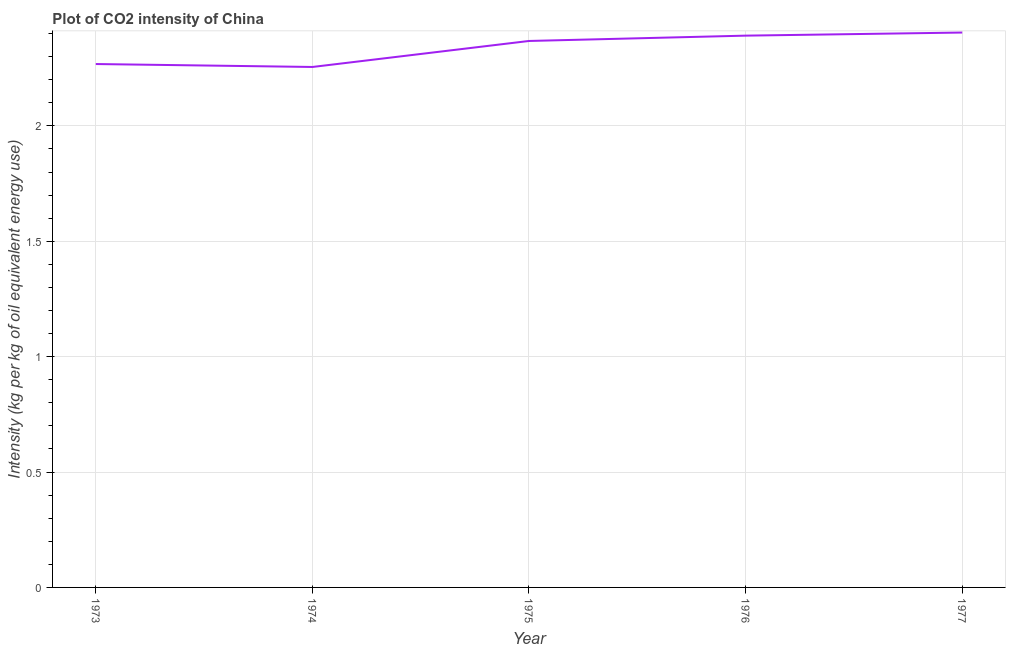What is the co2 intensity in 1973?
Provide a succinct answer. 2.27. Across all years, what is the maximum co2 intensity?
Provide a short and direct response. 2.4. Across all years, what is the minimum co2 intensity?
Ensure brevity in your answer.  2.26. In which year was the co2 intensity maximum?
Your answer should be compact. 1977. In which year was the co2 intensity minimum?
Your response must be concise. 1974. What is the sum of the co2 intensity?
Your answer should be very brief. 11.69. What is the difference between the co2 intensity in 1974 and 1976?
Give a very brief answer. -0.14. What is the average co2 intensity per year?
Keep it short and to the point. 2.34. What is the median co2 intensity?
Make the answer very short. 2.37. In how many years, is the co2 intensity greater than 0.7 kg?
Your answer should be compact. 5. Do a majority of the years between 1974 and 1973 (inclusive) have co2 intensity greater than 0.2 kg?
Offer a terse response. No. What is the ratio of the co2 intensity in 1974 to that in 1977?
Your answer should be very brief. 0.94. Is the difference between the co2 intensity in 1973 and 1974 greater than the difference between any two years?
Ensure brevity in your answer.  No. What is the difference between the highest and the second highest co2 intensity?
Your response must be concise. 0.01. What is the difference between the highest and the lowest co2 intensity?
Provide a short and direct response. 0.15. In how many years, is the co2 intensity greater than the average co2 intensity taken over all years?
Offer a very short reply. 3. Does the co2 intensity monotonically increase over the years?
Provide a short and direct response. No. What is the difference between two consecutive major ticks on the Y-axis?
Keep it short and to the point. 0.5. Does the graph contain any zero values?
Ensure brevity in your answer.  No. What is the title of the graph?
Offer a terse response. Plot of CO2 intensity of China. What is the label or title of the Y-axis?
Keep it short and to the point. Intensity (kg per kg of oil equivalent energy use). What is the Intensity (kg per kg of oil equivalent energy use) of 1973?
Provide a succinct answer. 2.27. What is the Intensity (kg per kg of oil equivalent energy use) of 1974?
Ensure brevity in your answer.  2.26. What is the Intensity (kg per kg of oil equivalent energy use) of 1975?
Your answer should be very brief. 2.37. What is the Intensity (kg per kg of oil equivalent energy use) of 1976?
Provide a succinct answer. 2.39. What is the Intensity (kg per kg of oil equivalent energy use) in 1977?
Your answer should be compact. 2.4. What is the difference between the Intensity (kg per kg of oil equivalent energy use) in 1973 and 1974?
Your answer should be very brief. 0.01. What is the difference between the Intensity (kg per kg of oil equivalent energy use) in 1973 and 1975?
Make the answer very short. -0.1. What is the difference between the Intensity (kg per kg of oil equivalent energy use) in 1973 and 1976?
Offer a terse response. -0.12. What is the difference between the Intensity (kg per kg of oil equivalent energy use) in 1973 and 1977?
Provide a succinct answer. -0.14. What is the difference between the Intensity (kg per kg of oil equivalent energy use) in 1974 and 1975?
Your answer should be compact. -0.11. What is the difference between the Intensity (kg per kg of oil equivalent energy use) in 1974 and 1976?
Offer a terse response. -0.14. What is the difference between the Intensity (kg per kg of oil equivalent energy use) in 1974 and 1977?
Offer a very short reply. -0.15. What is the difference between the Intensity (kg per kg of oil equivalent energy use) in 1975 and 1976?
Give a very brief answer. -0.02. What is the difference between the Intensity (kg per kg of oil equivalent energy use) in 1975 and 1977?
Give a very brief answer. -0.04. What is the difference between the Intensity (kg per kg of oil equivalent energy use) in 1976 and 1977?
Keep it short and to the point. -0.01. What is the ratio of the Intensity (kg per kg of oil equivalent energy use) in 1973 to that in 1975?
Your response must be concise. 0.96. What is the ratio of the Intensity (kg per kg of oil equivalent energy use) in 1973 to that in 1976?
Provide a short and direct response. 0.95. What is the ratio of the Intensity (kg per kg of oil equivalent energy use) in 1973 to that in 1977?
Offer a very short reply. 0.94. What is the ratio of the Intensity (kg per kg of oil equivalent energy use) in 1974 to that in 1976?
Make the answer very short. 0.94. What is the ratio of the Intensity (kg per kg of oil equivalent energy use) in 1974 to that in 1977?
Ensure brevity in your answer.  0.94. What is the ratio of the Intensity (kg per kg of oil equivalent energy use) in 1975 to that in 1976?
Your response must be concise. 0.99. 